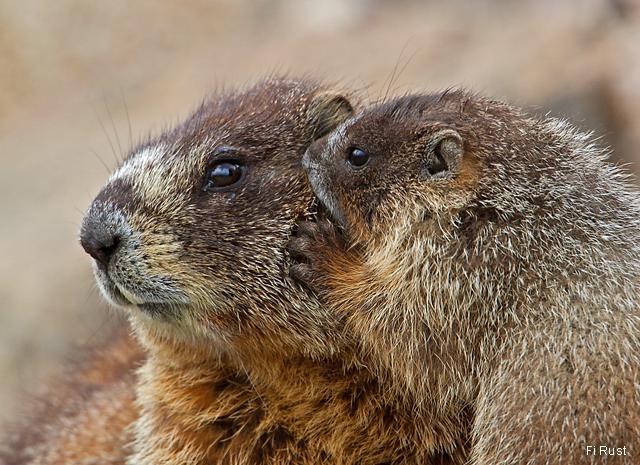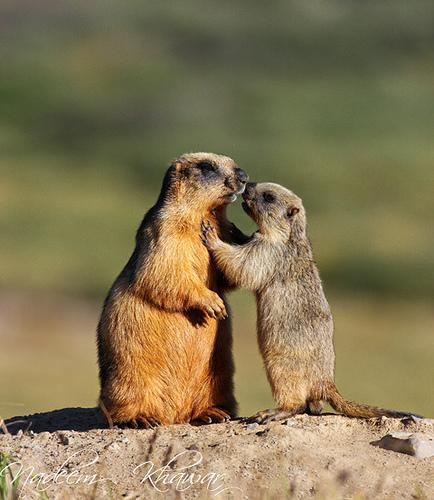The first image is the image on the left, the second image is the image on the right. Given the left and right images, does the statement "Marmots are standing on hind legs facing each other" hold true? Answer yes or no. Yes. The first image is the image on the left, the second image is the image on the right. Considering the images on both sides, is "There are 3 groundhogs that are not touching another groundhog." valid? Answer yes or no. No. 